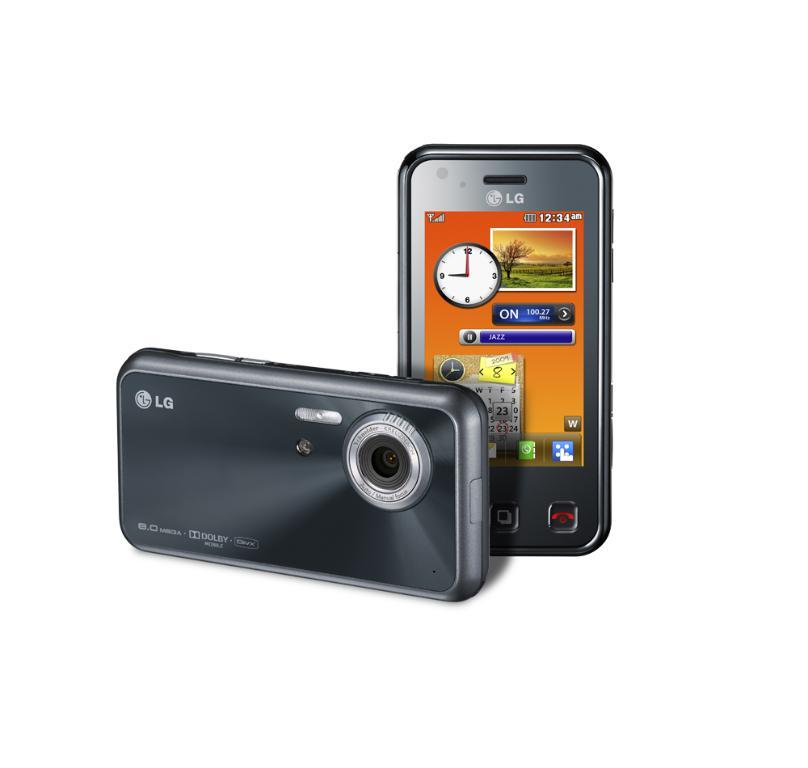<image>
Offer a succinct explanation of the picture presented. A LG camera show the time of 12:34 AM. 